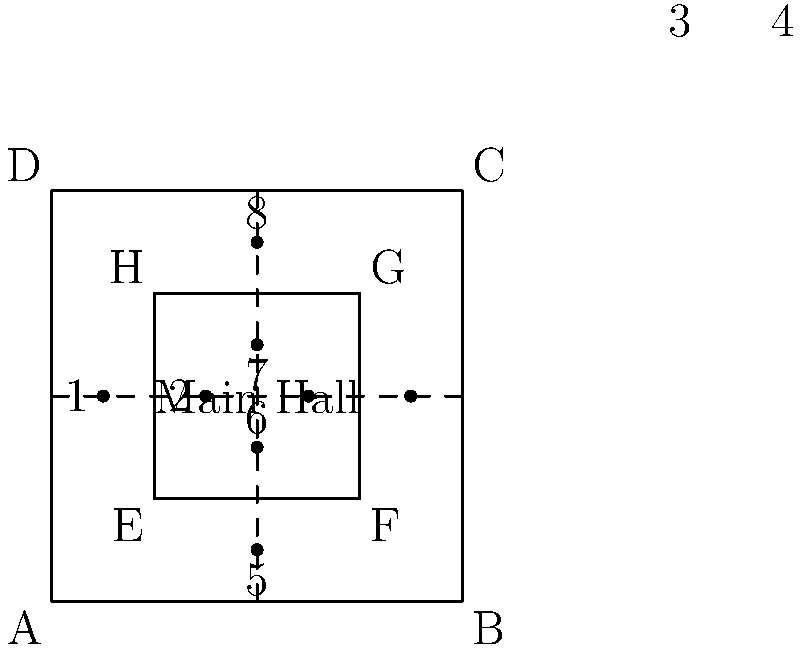In the layout for a multilateral peace talks venue shown above, which seating arrangement would be most conducive to maintaining neutrality and facilitating equal participation among eight delegations? To determine the most neutral and equal seating arrangement, we need to consider the following factors:

1. Equal distance from the center: All delegations should be equidistant from the center of the room to avoid perceived favoritism.

2. Symmetry: The arrangement should be symmetrical to reinforce the idea of equality.

3. Avoiding direct oppositions: Seating arrangements that place delegations directly across from each other might create an adversarial atmosphere.

4. Access to exits: All delegations should have equal access to exits for security and comfort.

Given these considerations:

1. The layout shows a square room with eight marked positions (1-8) arranged in a circular pattern around the center.

2. Positions 1-4 are along the horizontal axis, while 5-8 are along the vertical axis.

3. The arrangement is symmetrical, with each position having a counterpart on the opposite side of the center.

4. All positions are equidistant from the center of the room.

5. No delegation is seated directly opposite another, which could help reduce potential tensions.

6. Each position has equal access to the nearest exit (sides of the square).

Therefore, the seating arrangement of positions 1-8 as shown in the diagram provides the most neutral and equal setup for the eight delegations participating in the peace talks.
Answer: Positions 1-8 as marked in the diagram 